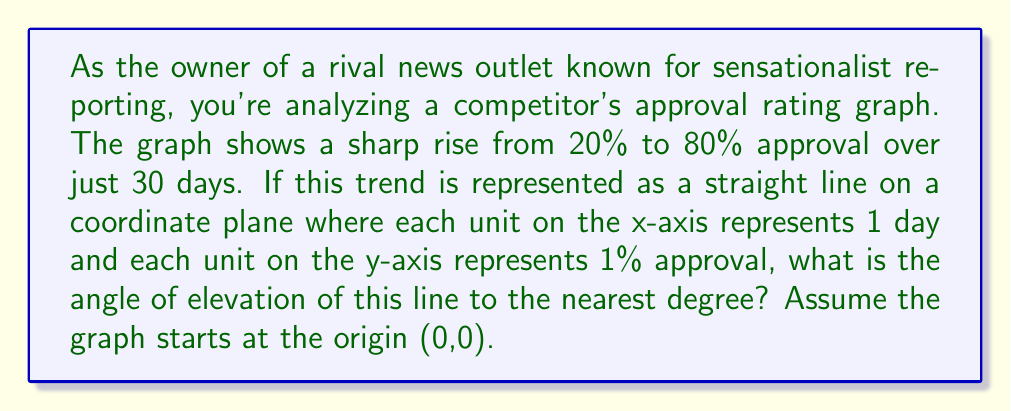Help me with this question. To solve this problem, we need to use trigonometry. Let's approach this step-by-step:

1) First, let's identify the points on the coordinate plane:
   Start point: (0, 20)
   End point: (30, 80)

2) We can treat this as a right triangle, where:
   - The base (run) is the change in x: 30 days
   - The height (rise) is the change in y: 80% - 20% = 60%

3) To find the angle of elevation, we need to use the arctangent function:

   $$\theta = \arctan(\frac{\text{rise}}{\text{run}})$$

4) Plugging in our values:

   $$\theta = \arctan(\frac{60}{30})$$

5) Simplify:

   $$\theta = \arctan(2)$$

6) Using a calculator or trigonometric table:

   $$\theta \approx 63.4349...°$$

7) Rounding to the nearest degree:

   $$\theta \approx 63°$$

[asy]
unitsize(4mm);
draw((0,0)--(30,0)--(30,60)--(0,0), black);
draw((0,0)--(30,60), red+1);
label("30 days", (15,-2), S);
label("60%", (32,30), E);
label("θ", (3,5), NW);
[/asy]
Answer: The angle of elevation of the approval rating graph is approximately 63°. 